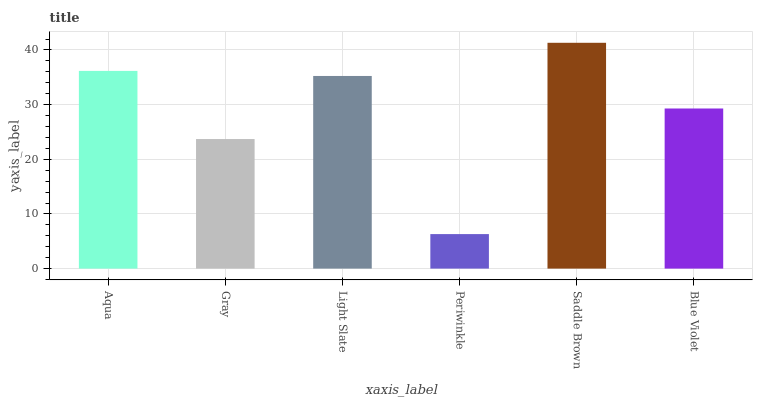Is Periwinkle the minimum?
Answer yes or no. Yes. Is Saddle Brown the maximum?
Answer yes or no. Yes. Is Gray the minimum?
Answer yes or no. No. Is Gray the maximum?
Answer yes or no. No. Is Aqua greater than Gray?
Answer yes or no. Yes. Is Gray less than Aqua?
Answer yes or no. Yes. Is Gray greater than Aqua?
Answer yes or no. No. Is Aqua less than Gray?
Answer yes or no. No. Is Light Slate the high median?
Answer yes or no. Yes. Is Blue Violet the low median?
Answer yes or no. Yes. Is Periwinkle the high median?
Answer yes or no. No. Is Periwinkle the low median?
Answer yes or no. No. 